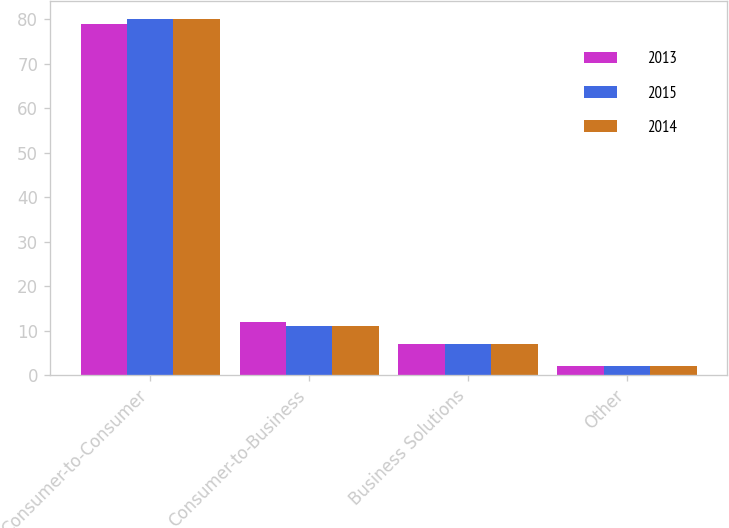Convert chart to OTSL. <chart><loc_0><loc_0><loc_500><loc_500><stacked_bar_chart><ecel><fcel>Consumer-to-Consumer<fcel>Consumer-to-Business<fcel>Business Solutions<fcel>Other<nl><fcel>2013<fcel>79<fcel>12<fcel>7<fcel>2<nl><fcel>2015<fcel>80<fcel>11<fcel>7<fcel>2<nl><fcel>2014<fcel>80<fcel>11<fcel>7<fcel>2<nl></chart> 